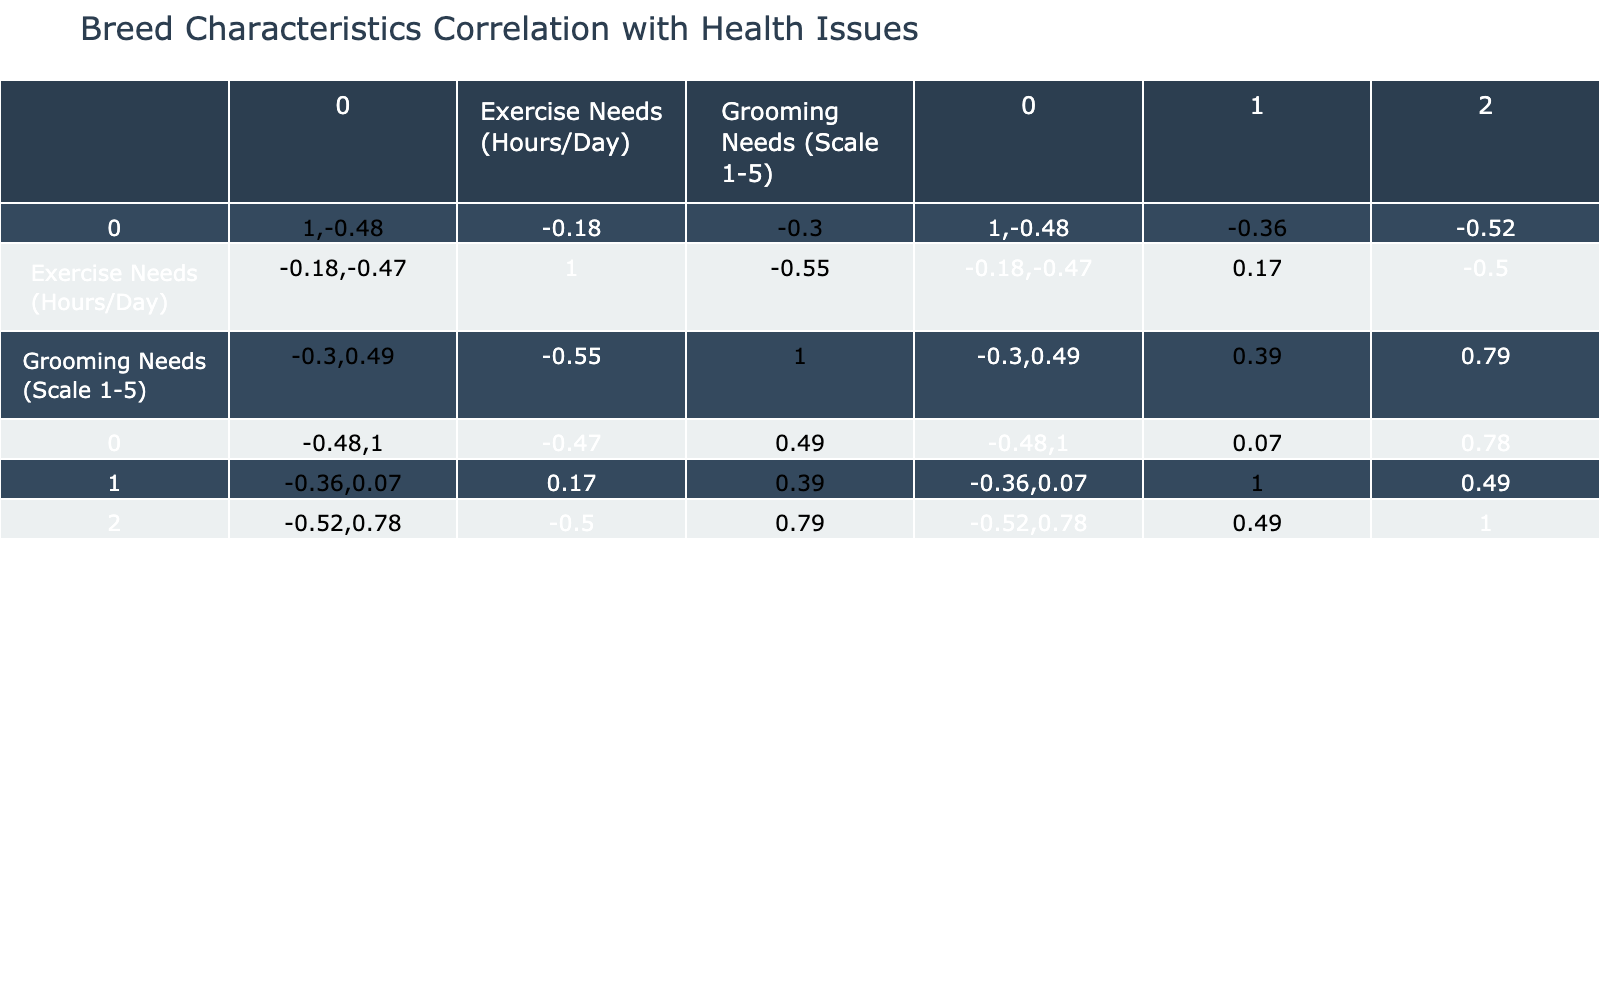What breed has the highest prevalence of health issues? By looking at the "Prevalence of Health Issues (%)" column, we find the Bulldog with a prevalence of 35%, which is higher than all other breeds in the table.
Answer: Bulldog What is the average lifespan of a Rottweiler? The average lifespan for a Rottweiler is between 8-10 years, which can be interpreted as approximately 9 years when averaged.
Answer: 9 years Which breed requires the most grooming? The Shih Tzu has a grooming needs scale of 5, which is the highest in the table compared to other breeds.
Answer: Shih Tzu Is there a breed with a lifespan greater than 15 years? No, all the breeds listed have an average lifespan not exceeding 16 years, with the maximum average lifespan being 16 years for Dachshund.
Answer: No What is the combined prevalence of health issues for the Beagle and Poodle? The Beagle has a prevalence of health issues at 20% (Ear Infections: 20%, Obesity: 15%, Eye Disorders: 10%), and the Poodle has 15% (Advanced Age Issues: 15%, Skin Conditions: 20%, Hip Dysplasia: 10%). Adding these percentages gives us (20 + 15) = 35% for combined prevalence.
Answer: 35% Which breed has the lowest exercise needs? The Bulldog has the lowest exercise needs, at 0.5-1 hour per day, which is less than the exercise needs of any other breeds.
Answer: Bulldog What health issue is most common among breeds that have a lifespan of 12-15 years? The most prevalent health issue among breeds with a lifespan of 12-15 years (Beagle, Poodle, Siberian Husky) is obesity, which is common in both Beagle and Poodle.
Answer: Obesity Can we infer that breeds with higher grooming needs also experience more common health issues? More data points are necessary for confirmation, but observing the table, Bulldog, which has the highest grooming needs (scale 4) has a prevalence of 35%, indicating a possible correlation. However, Shih Tzu with scale 5 has only a prevalence of 30%. Hence, we cannot definitively conclude this correlation based on available data.
Answer: No definite correlation What is the average prevalence of health issues for dogs that require at least 2 hours of exercise per day? From the table, the only breed requiring 2 hours of exercise per day is the Siberian Husky with a prevalence of 15%. Hence, the average is also 15%.
Answer: 15% 